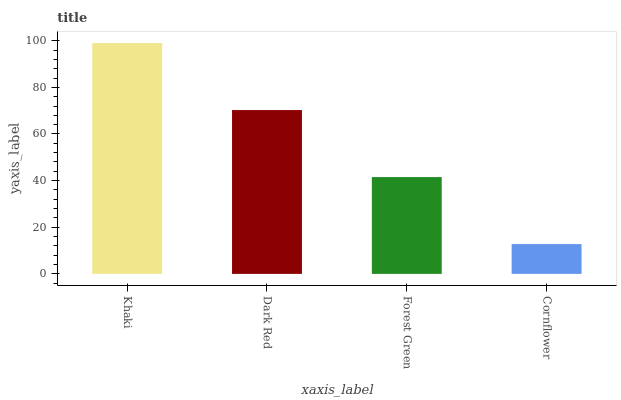Is Cornflower the minimum?
Answer yes or no. Yes. Is Khaki the maximum?
Answer yes or no. Yes. Is Dark Red the minimum?
Answer yes or no. No. Is Dark Red the maximum?
Answer yes or no. No. Is Khaki greater than Dark Red?
Answer yes or no. Yes. Is Dark Red less than Khaki?
Answer yes or no. Yes. Is Dark Red greater than Khaki?
Answer yes or no. No. Is Khaki less than Dark Red?
Answer yes or no. No. Is Dark Red the high median?
Answer yes or no. Yes. Is Forest Green the low median?
Answer yes or no. Yes. Is Forest Green the high median?
Answer yes or no. No. Is Dark Red the low median?
Answer yes or no. No. 